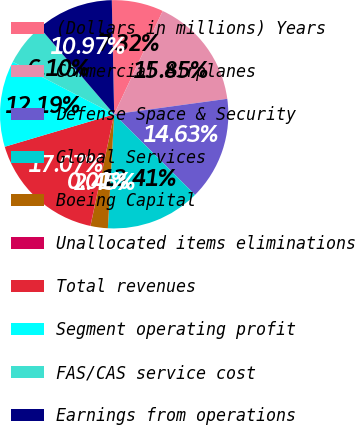Convert chart to OTSL. <chart><loc_0><loc_0><loc_500><loc_500><pie_chart><fcel>(Dollars in millions) Years<fcel>Commercial Airplanes<fcel>Defense Space & Security<fcel>Global Services<fcel>Boeing Capital<fcel>Unallocated items eliminations<fcel>Total revenues<fcel>Segment operating profit<fcel>FAS/CAS service cost<fcel>Earnings from operations<nl><fcel>7.32%<fcel>15.85%<fcel>14.63%<fcel>13.41%<fcel>2.45%<fcel>0.01%<fcel>17.07%<fcel>12.19%<fcel>6.1%<fcel>10.97%<nl></chart> 